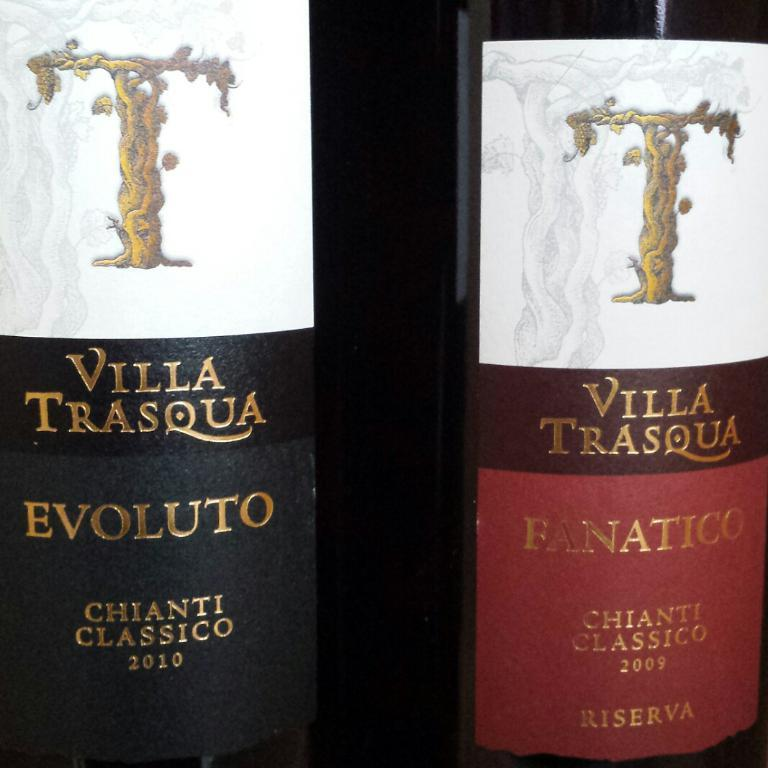<image>
Provide a brief description of the given image. two bottles of red Villa Trasqua chianti classico 